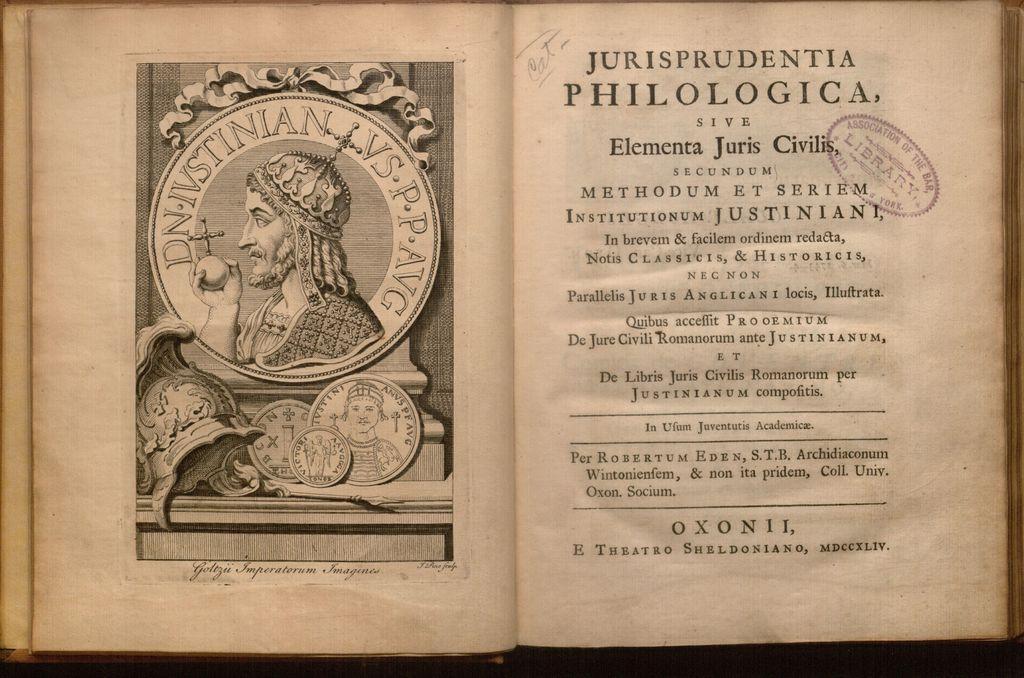Please provide a concise description of this image. In this image I can see an open book. There is a image on the left and some matter and stamp is present on the right. 